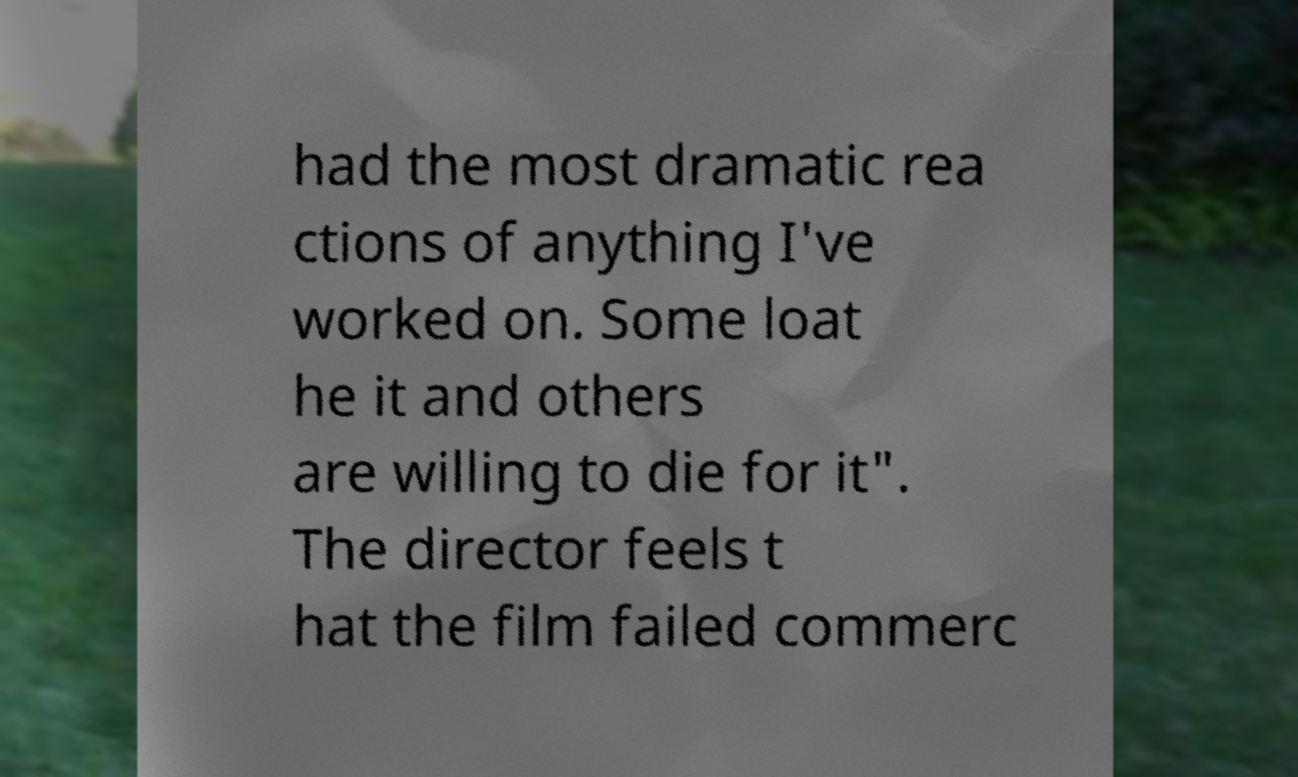Please identify and transcribe the text found in this image. had the most dramatic rea ctions of anything I've worked on. Some loat he it and others are willing to die for it". The director feels t hat the film failed commerc 